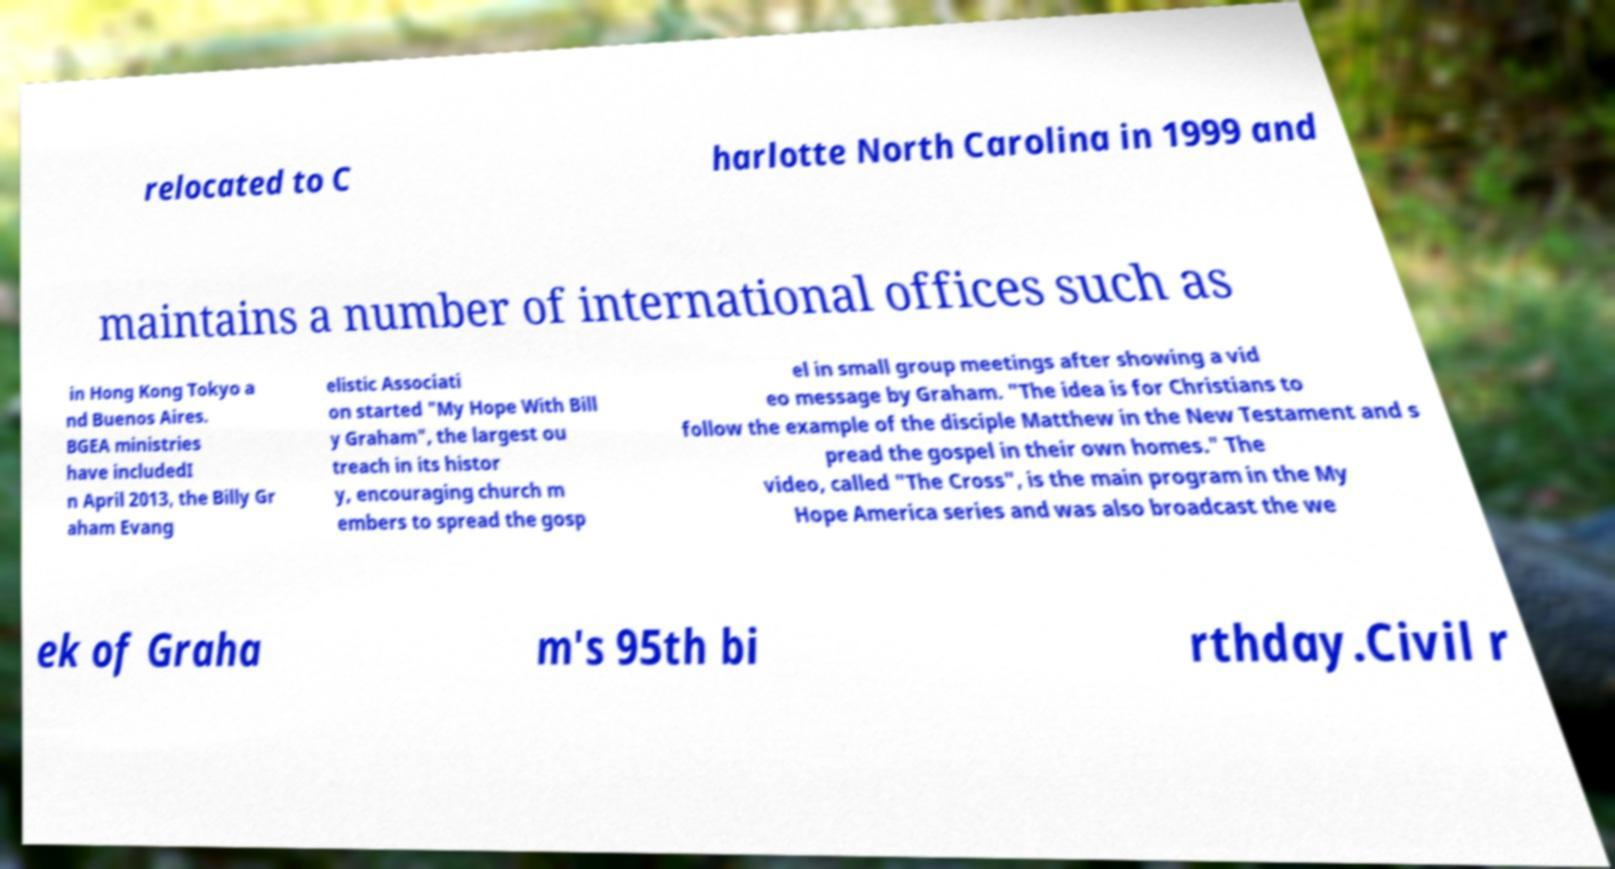Can you read and provide the text displayed in the image?This photo seems to have some interesting text. Can you extract and type it out for me? relocated to C harlotte North Carolina in 1999 and maintains a number of international offices such as in Hong Kong Tokyo a nd Buenos Aires. BGEA ministries have includedI n April 2013, the Billy Gr aham Evang elistic Associati on started "My Hope With Bill y Graham", the largest ou treach in its histor y, encouraging church m embers to spread the gosp el in small group meetings after showing a vid eo message by Graham. "The idea is for Christians to follow the example of the disciple Matthew in the New Testament and s pread the gospel in their own homes." The video, called "The Cross", is the main program in the My Hope America series and was also broadcast the we ek of Graha m's 95th bi rthday.Civil r 